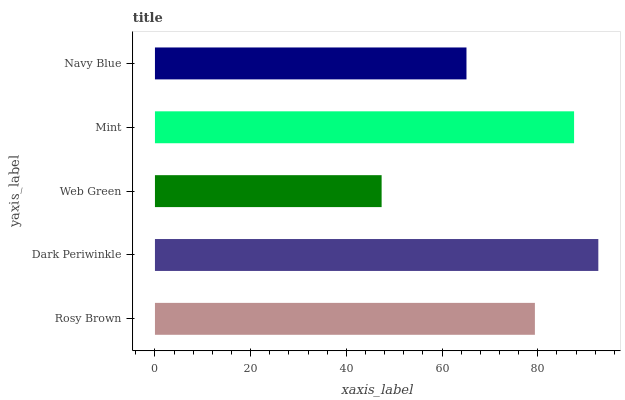Is Web Green the minimum?
Answer yes or no. Yes. Is Dark Periwinkle the maximum?
Answer yes or no. Yes. Is Dark Periwinkle the minimum?
Answer yes or no. No. Is Web Green the maximum?
Answer yes or no. No. Is Dark Periwinkle greater than Web Green?
Answer yes or no. Yes. Is Web Green less than Dark Periwinkle?
Answer yes or no. Yes. Is Web Green greater than Dark Periwinkle?
Answer yes or no. No. Is Dark Periwinkle less than Web Green?
Answer yes or no. No. Is Rosy Brown the high median?
Answer yes or no. Yes. Is Rosy Brown the low median?
Answer yes or no. Yes. Is Web Green the high median?
Answer yes or no. No. Is Dark Periwinkle the low median?
Answer yes or no. No. 